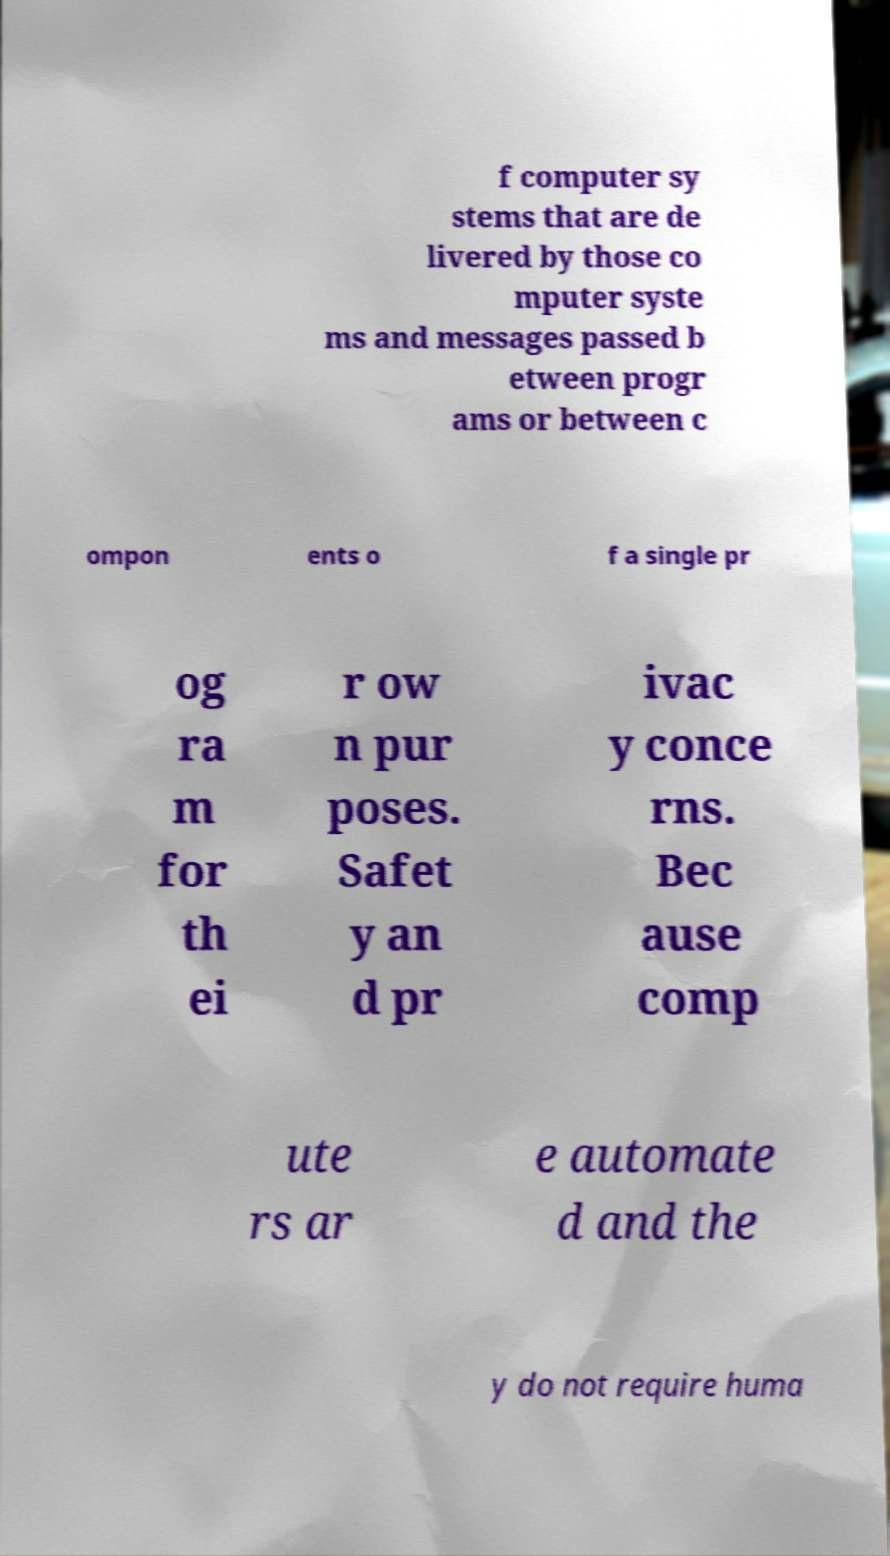I need the written content from this picture converted into text. Can you do that? f computer sy stems that are de livered by those co mputer syste ms and messages passed b etween progr ams or between c ompon ents o f a single pr og ra m for th ei r ow n pur poses. Safet y an d pr ivac y conce rns. Bec ause comp ute rs ar e automate d and the y do not require huma 